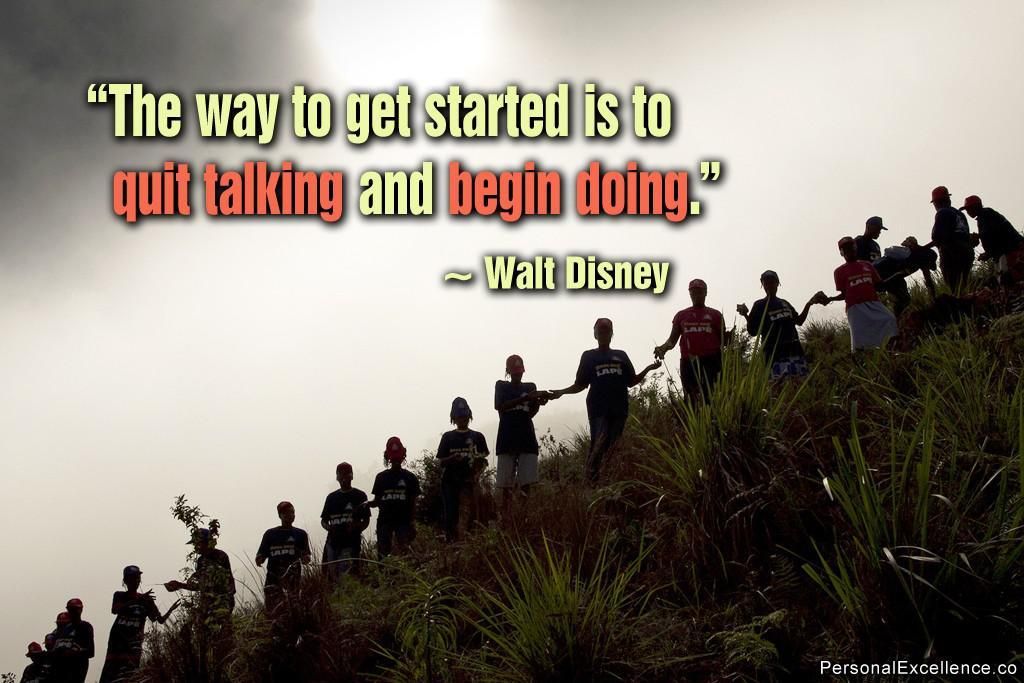<image>
Share a concise interpretation of the image provided. A poster with a quote from Walt Disney. 